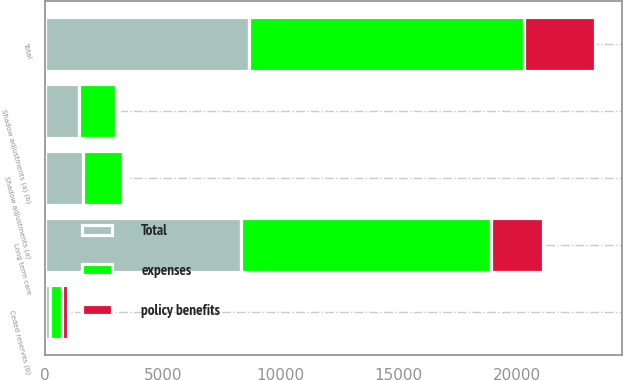Convert chart to OTSL. <chart><loc_0><loc_0><loc_500><loc_500><stacked_bar_chart><ecel><fcel>Total<fcel>Shadow adjustments (a) (b)<fcel>Long term care<fcel>Shadow adjustments (a)<fcel>Ceded reserves (b)<nl><fcel>policy benefits<fcel>3008<fcel>101<fcel>2229<fcel>99<fcel>290<nl><fcel>Total<fcel>8654<fcel>1459<fcel>8335<fcel>1610<fcel>207<nl><fcel>expenses<fcel>11662<fcel>1560<fcel>10564<fcel>1709<fcel>497<nl></chart> 